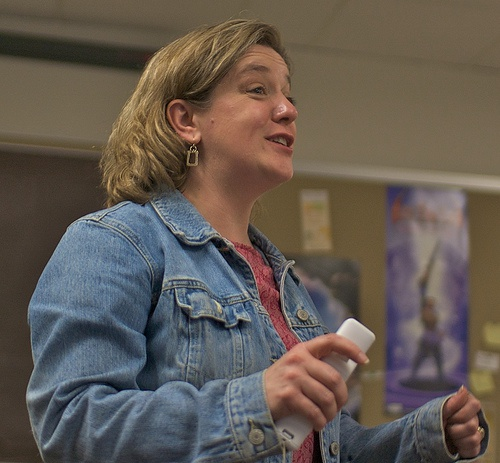Describe the objects in this image and their specific colors. I can see people in gray, brown, and black tones and remote in gray, darkgray, and maroon tones in this image. 